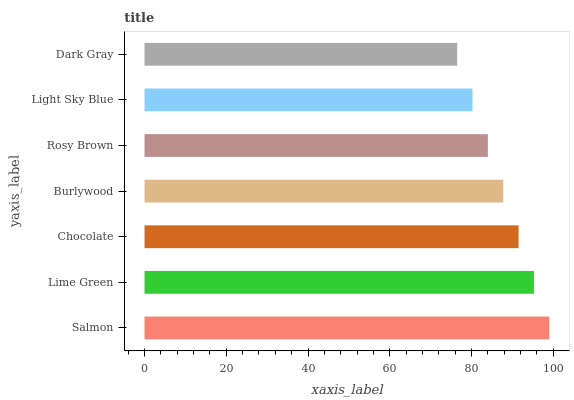Is Dark Gray the minimum?
Answer yes or no. Yes. Is Salmon the maximum?
Answer yes or no. Yes. Is Lime Green the minimum?
Answer yes or no. No. Is Lime Green the maximum?
Answer yes or no. No. Is Salmon greater than Lime Green?
Answer yes or no. Yes. Is Lime Green less than Salmon?
Answer yes or no. Yes. Is Lime Green greater than Salmon?
Answer yes or no. No. Is Salmon less than Lime Green?
Answer yes or no. No. Is Burlywood the high median?
Answer yes or no. Yes. Is Burlywood the low median?
Answer yes or no. Yes. Is Lime Green the high median?
Answer yes or no. No. Is Lime Green the low median?
Answer yes or no. No. 